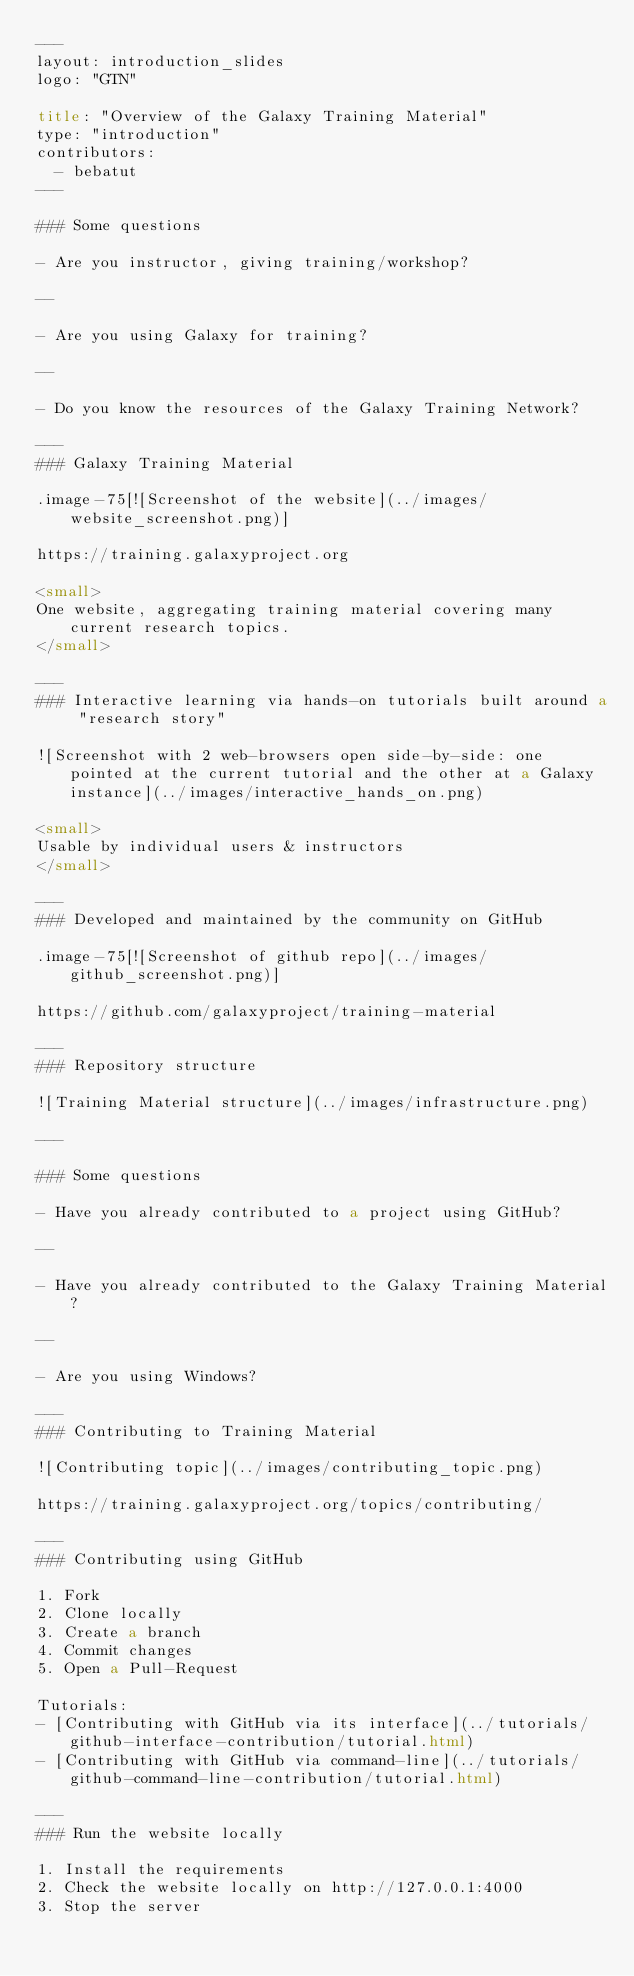<code> <loc_0><loc_0><loc_500><loc_500><_HTML_>---
layout: introduction_slides
logo: "GTN"

title: "Overview of the Galaxy Training Material"
type: "introduction"
contributors:
  - bebatut
---

### Some questions

- Are you instructor, giving training/workshop?

--

- Are you using Galaxy for training?

--

- Do you know the resources of the Galaxy Training Network?

---
### Galaxy Training Material

.image-75[![Screenshot of the website](../images/website_screenshot.png)]

https://training.galaxyproject.org

<small>
One website, aggregating training material covering many current research topics.
</small>

---
### Interactive learning via hands-on tutorials built around a "research story"

![Screenshot with 2 web-browsers open side-by-side: one pointed at the current tutorial and the other at a Galaxy instance](../images/interactive_hands_on.png)

<small>
Usable by individual users & instructors
</small>

---
### Developed and maintained by the community on GitHub

.image-75[![Screenshot of github repo](../images/github_screenshot.png)]

https://github.com/galaxyproject/training-material

---
### Repository structure

![Training Material structure](../images/infrastructure.png)

---

### Some questions

- Have you already contributed to a project using GitHub?

--

- Have you already contributed to the Galaxy Training Material?

--

- Are you using Windows?

---
### Contributing to Training Material

![Contributing topic](../images/contributing_topic.png)

https://training.galaxyproject.org/topics/contributing/

---
### Contributing using GitHub

1. Fork
2. Clone locally
3. Create a branch
4. Commit changes
5. Open a Pull-Request

Tutorials:
- [Contributing with GitHub via its interface](../tutorials/github-interface-contribution/tutorial.html)
- [Contributing with GitHub via command-line](../tutorials/github-command-line-contribution/tutorial.html)

---
### Run the website locally

1. Install the requirements
2. Check the website locally on http://127.0.0.1:4000
3. Stop the server
</code> 